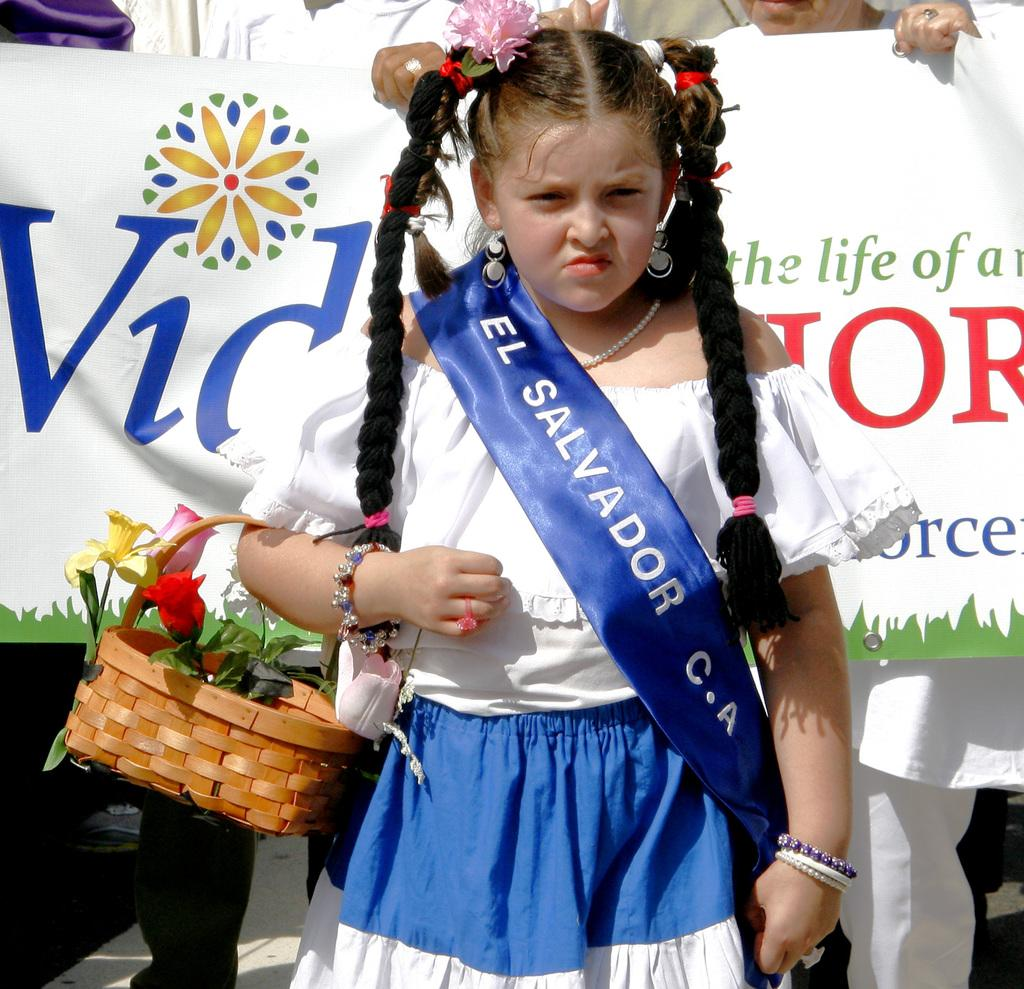<image>
Give a short and clear explanation of the subsequent image. girl wearing el salvador slash over her dress with basket of flowers 